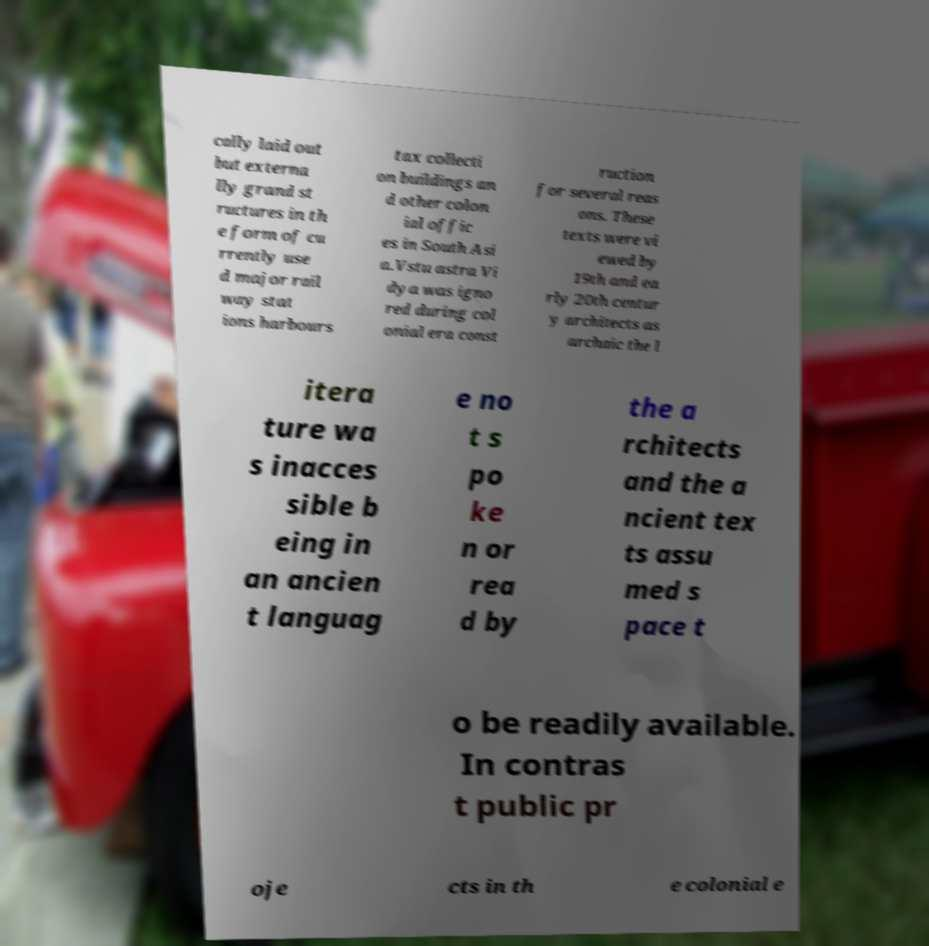What messages or text are displayed in this image? I need them in a readable, typed format. cally laid out but externa lly grand st ructures in th e form of cu rrently use d major rail way stat ions harbours tax collecti on buildings an d other colon ial offic es in South Asi a.Vstu astra Vi dya was igno red during col onial era const ruction for several reas ons. These texts were vi ewed by 19th and ea rly 20th centur y architects as archaic the l itera ture wa s inacces sible b eing in an ancien t languag e no t s po ke n or rea d by the a rchitects and the a ncient tex ts assu med s pace t o be readily available. In contras t public pr oje cts in th e colonial e 